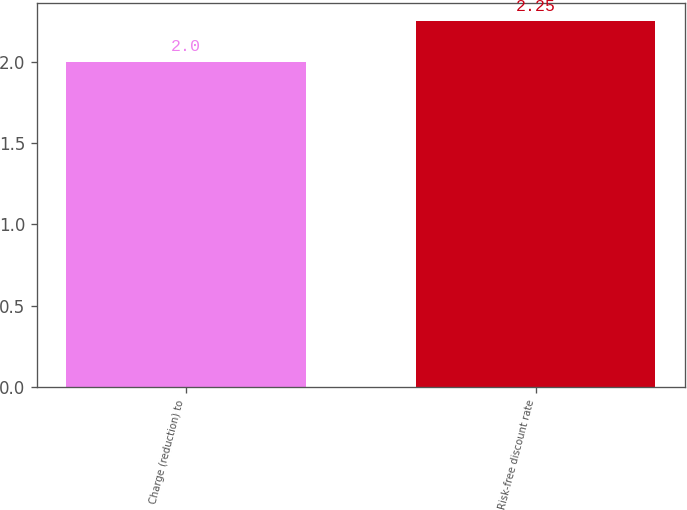Convert chart. <chart><loc_0><loc_0><loc_500><loc_500><bar_chart><fcel>Charge (reduction) to<fcel>Risk-free discount rate<nl><fcel>2<fcel>2.25<nl></chart> 